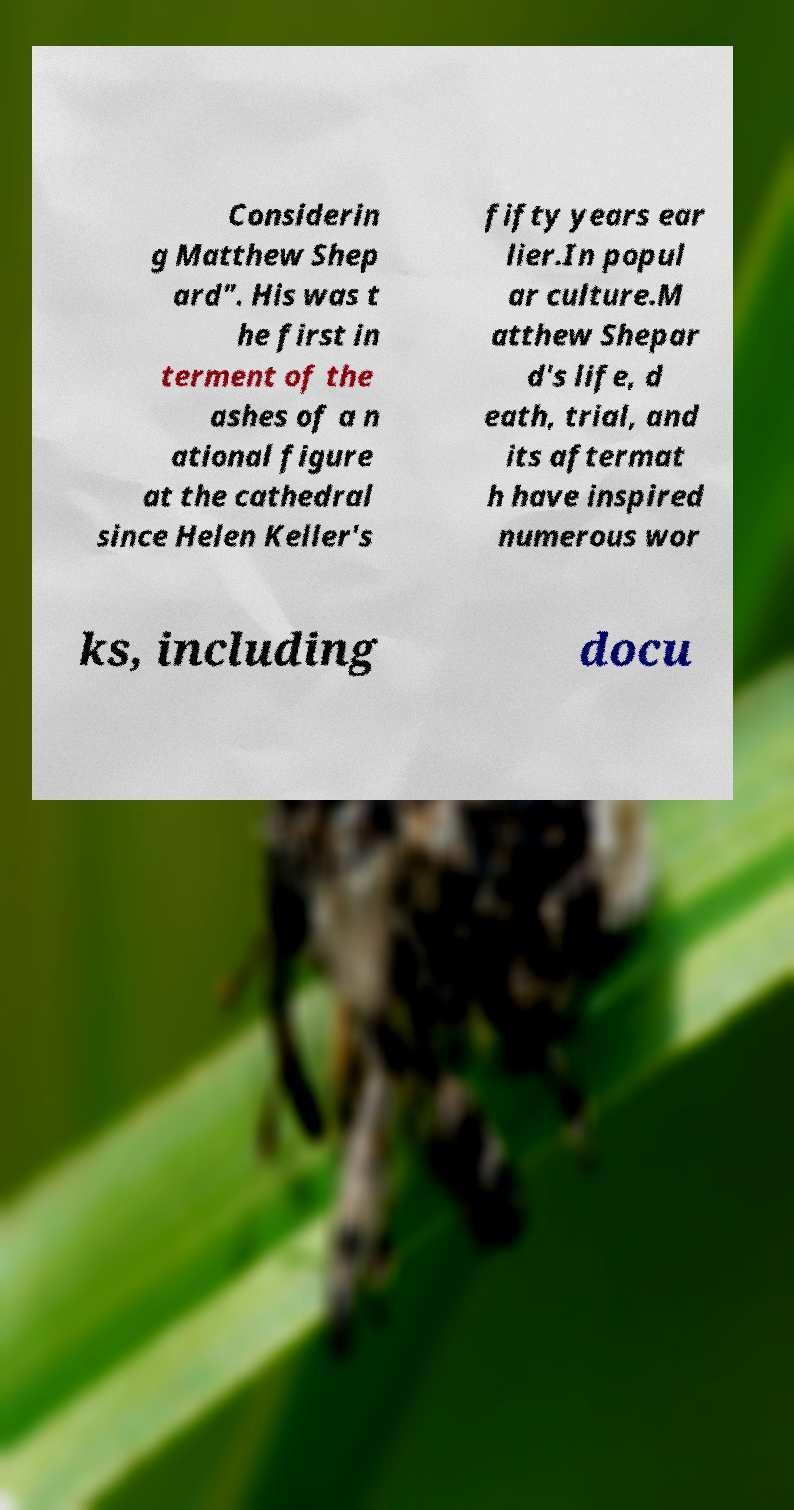Please read and relay the text visible in this image. What does it say? Considerin g Matthew Shep ard". His was t he first in terment of the ashes of a n ational figure at the cathedral since Helen Keller's fifty years ear lier.In popul ar culture.M atthew Shepar d's life, d eath, trial, and its aftermat h have inspired numerous wor ks, including docu 